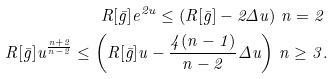Convert formula to latex. <formula><loc_0><loc_0><loc_500><loc_500>R [ \bar { g } ] e ^ { 2 u } \leq \left ( R [ \bar { g } ] - 2 \Delta u \right ) \, n = 2 \, \\ R [ \bar { g } ] u ^ { \frac { n + 2 } { n - 2 } } \leq \left ( R [ \bar { g } ] u - \frac { 4 ( n - 1 ) } { n - 2 } \Delta u \right ) \, n \geq 3 .</formula> 